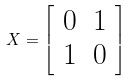Convert formula to latex. <formula><loc_0><loc_0><loc_500><loc_500>X = { \left [ \begin{array} { l l } { 0 } & { 1 } \\ { 1 } & { 0 } \end{array} \right ] }</formula> 